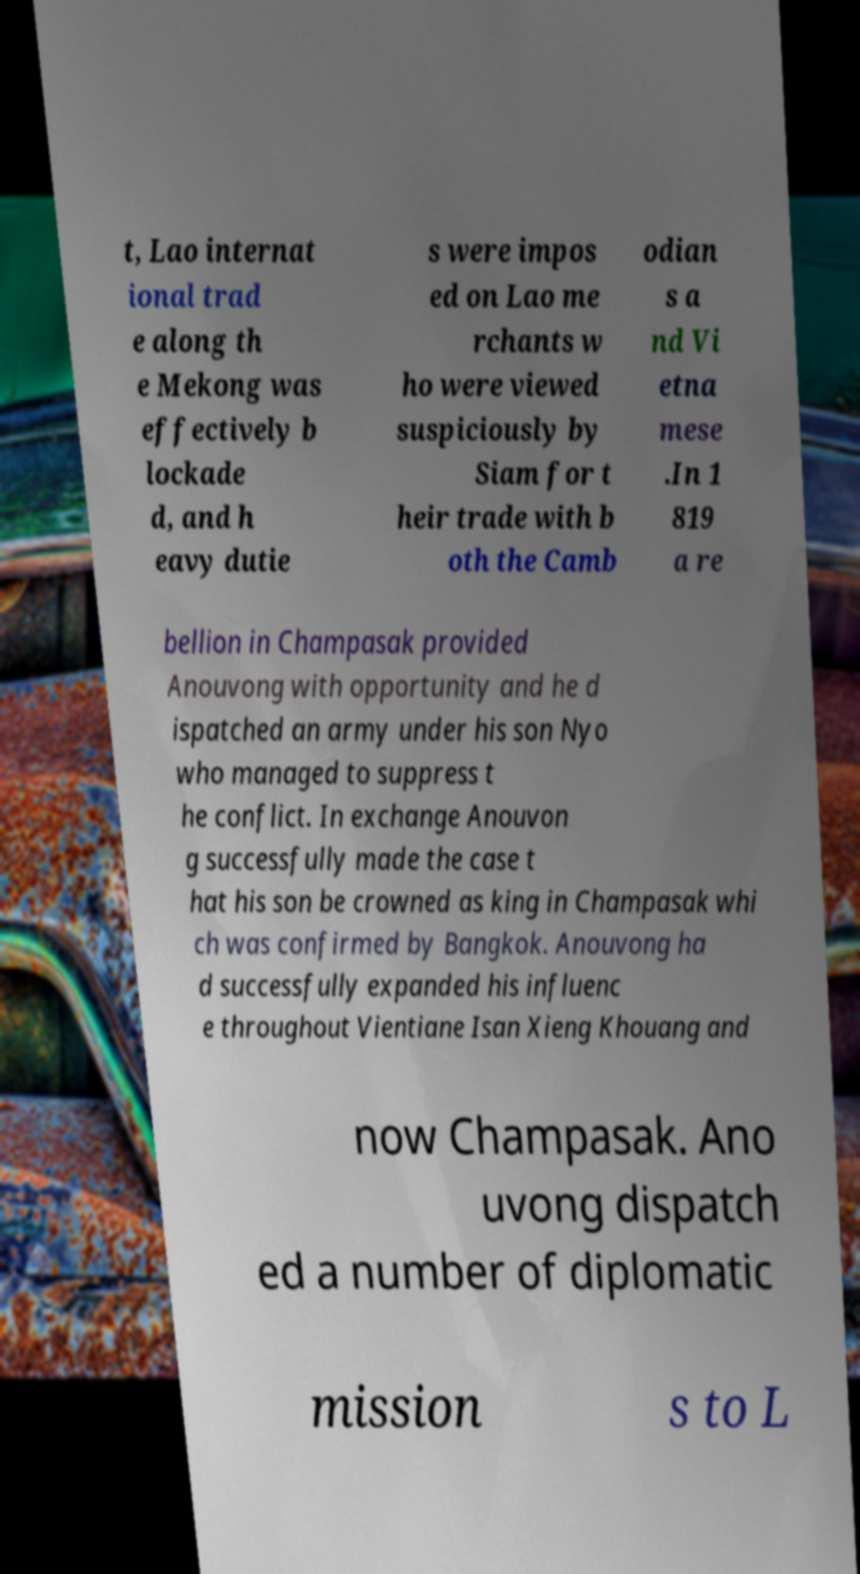Please read and relay the text visible in this image. What does it say? t, Lao internat ional trad e along th e Mekong was effectively b lockade d, and h eavy dutie s were impos ed on Lao me rchants w ho were viewed suspiciously by Siam for t heir trade with b oth the Camb odian s a nd Vi etna mese .In 1 819 a re bellion in Champasak provided Anouvong with opportunity and he d ispatched an army under his son Nyo who managed to suppress t he conflict. In exchange Anouvon g successfully made the case t hat his son be crowned as king in Champasak whi ch was confirmed by Bangkok. Anouvong ha d successfully expanded his influenc e throughout Vientiane Isan Xieng Khouang and now Champasak. Ano uvong dispatch ed a number of diplomatic mission s to L 